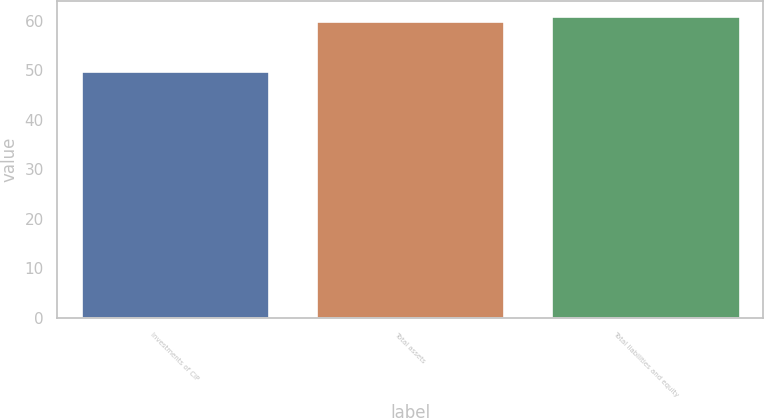Convert chart. <chart><loc_0><loc_0><loc_500><loc_500><bar_chart><fcel>Investments of CIP<fcel>Total assets<fcel>Total liabilities and equity<nl><fcel>49.9<fcel>59.9<fcel>60.9<nl></chart> 